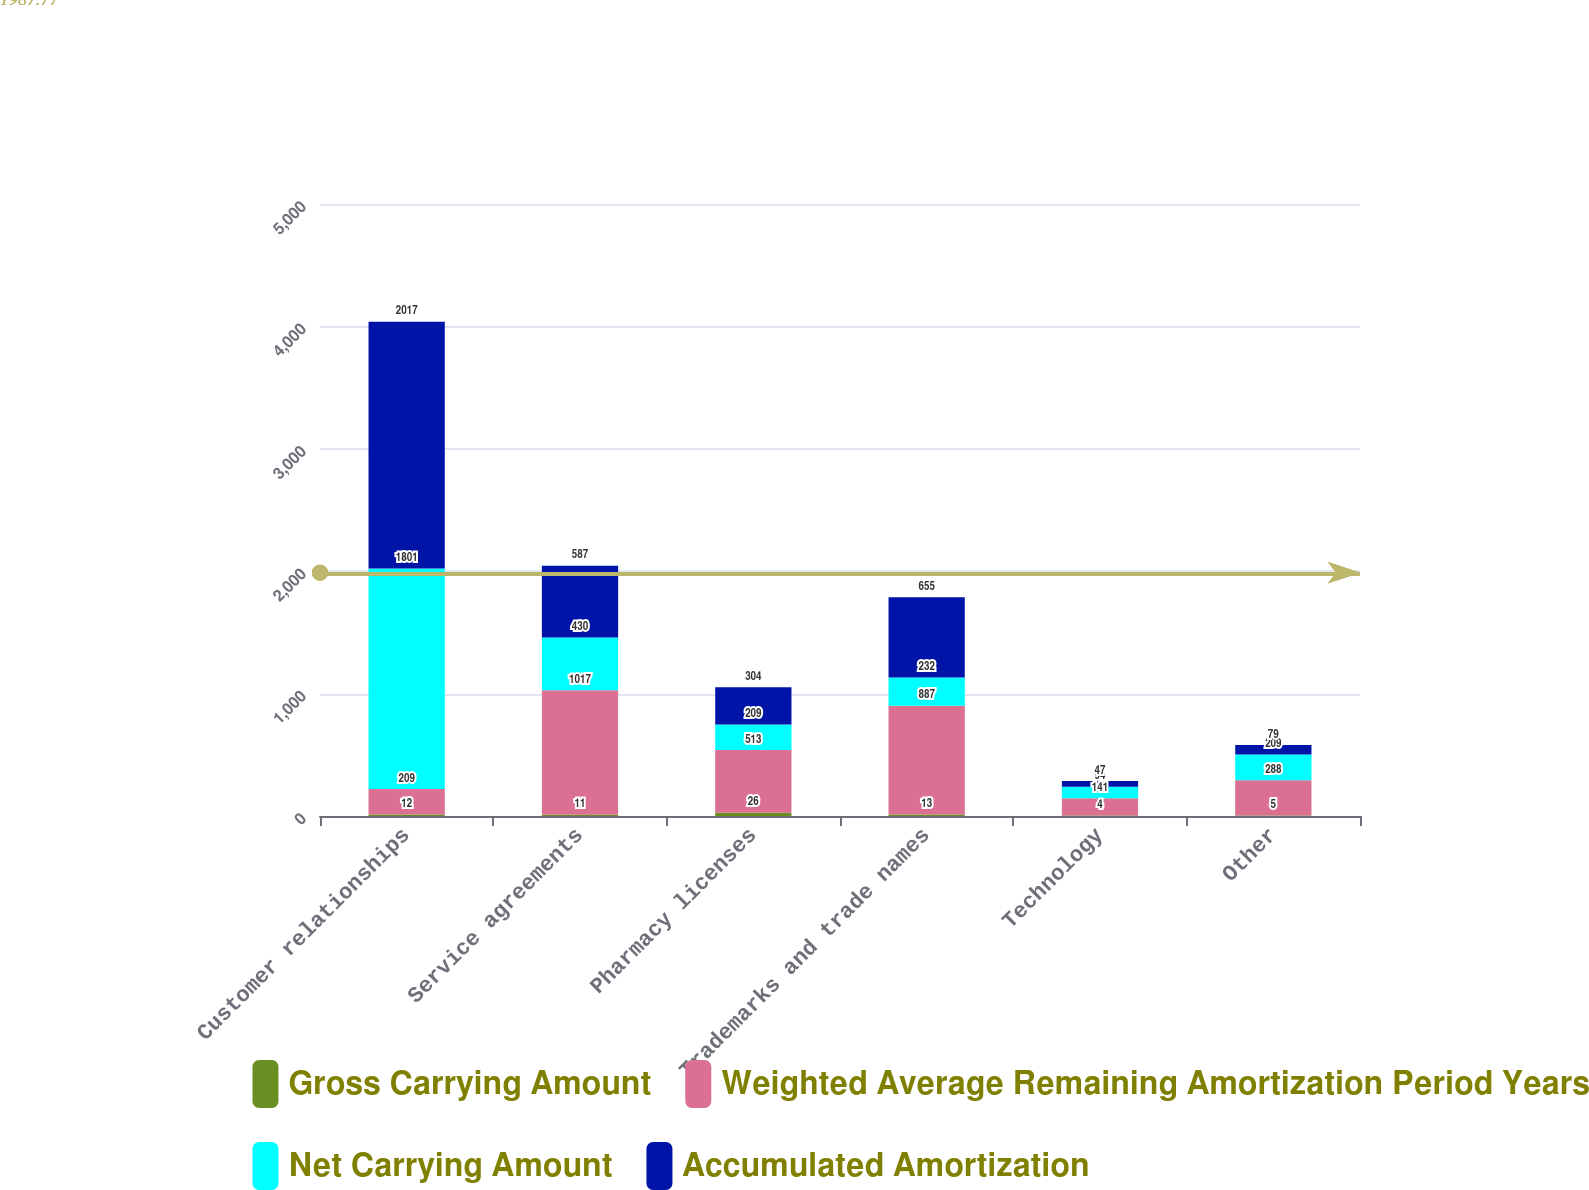Convert chart to OTSL. <chart><loc_0><loc_0><loc_500><loc_500><stacked_bar_chart><ecel><fcel>Customer relationships<fcel>Service agreements<fcel>Pharmacy licenses<fcel>Trademarks and trade names<fcel>Technology<fcel>Other<nl><fcel>Gross Carrying Amount<fcel>12<fcel>11<fcel>26<fcel>13<fcel>4<fcel>5<nl><fcel>Weighted Average Remaining Amortization Period Years<fcel>209<fcel>1017<fcel>513<fcel>887<fcel>141<fcel>288<nl><fcel>Net Carrying Amount<fcel>1801<fcel>430<fcel>209<fcel>232<fcel>94<fcel>209<nl><fcel>Accumulated Amortization<fcel>2017<fcel>587<fcel>304<fcel>655<fcel>47<fcel>79<nl></chart> 